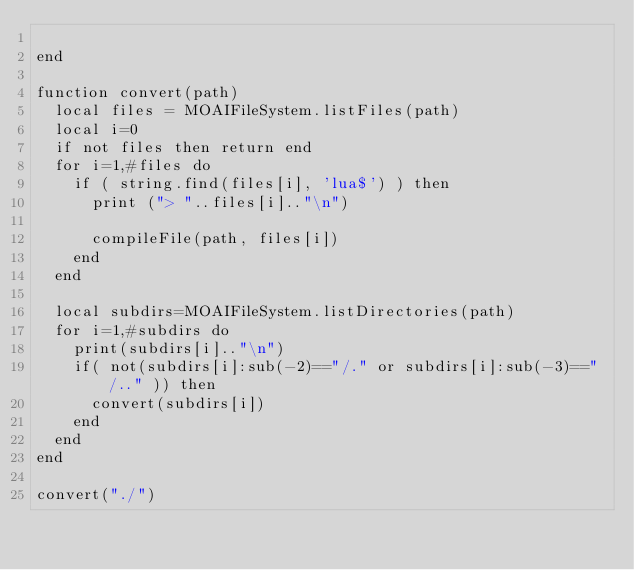Convert code to text. <code><loc_0><loc_0><loc_500><loc_500><_Lua_>
end

function convert(path)
  local files = MOAIFileSystem.listFiles(path)
  local i=0
  if not files then return end
  for i=1,#files do
    if ( string.find(files[i], 'lua$') ) then
      print ("> "..files[i].."\n")

      compileFile(path, files[i])
    end
  end

  local subdirs=MOAIFileSystem.listDirectories(path)
  for i=1,#subdirs do
    print(subdirs[i].."\n")
    if( not(subdirs[i]:sub(-2)=="/." or subdirs[i]:sub(-3)=="/.." )) then
      convert(subdirs[i])
    end
  end
end

convert("./")
</code> 